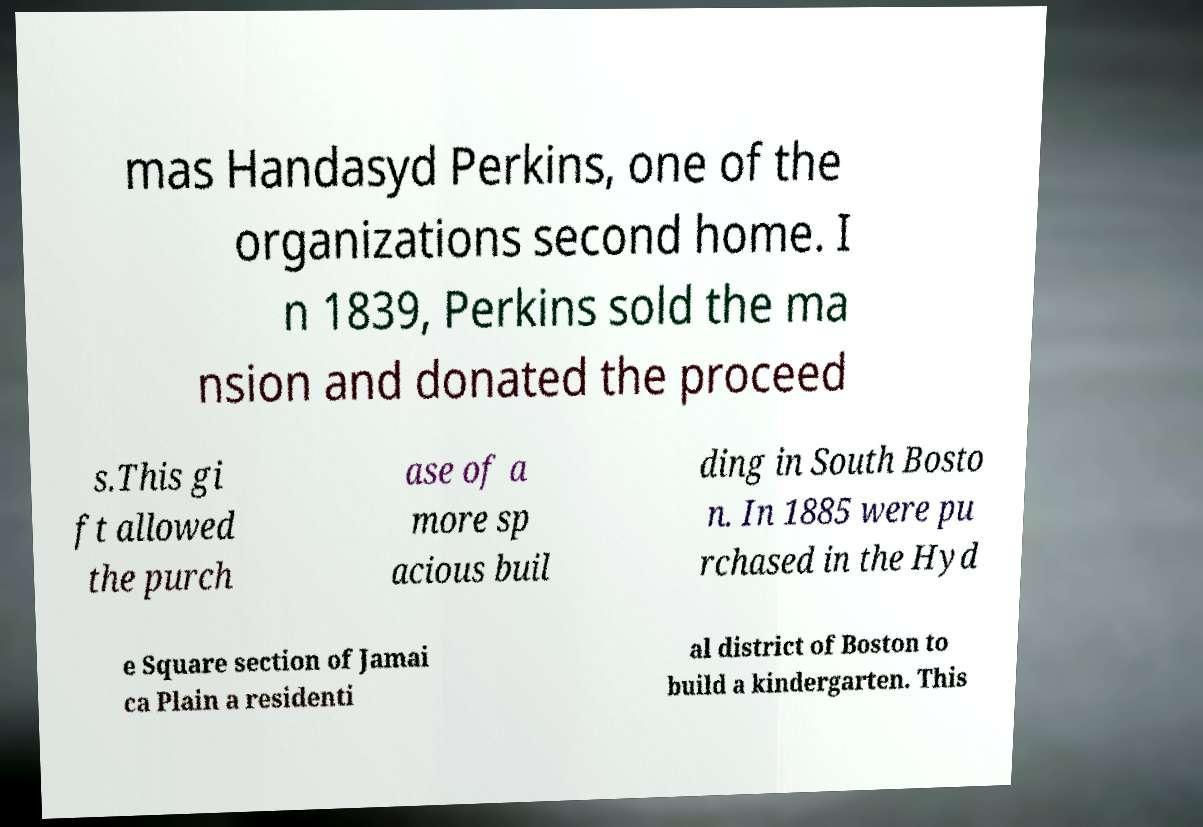Could you extract and type out the text from this image? mas Handasyd Perkins, one of the organizations second home. I n 1839, Perkins sold the ma nsion and donated the proceed s.This gi ft allowed the purch ase of a more sp acious buil ding in South Bosto n. In 1885 were pu rchased in the Hyd e Square section of Jamai ca Plain a residenti al district of Boston to build a kindergarten. This 